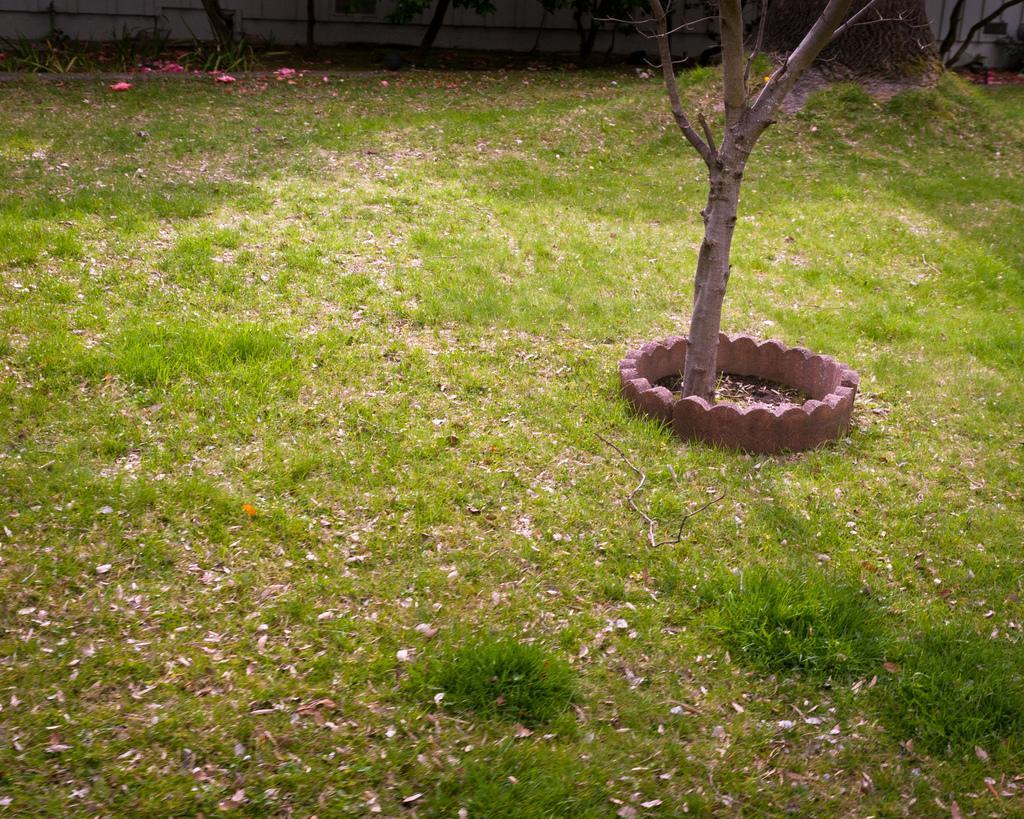Could you give a brief overview of what you see in this image? In the foreground of this image, there is a grassland. There is a tree in the middle and the stone boundary to it. On the top, it seems like there are trees and the wall. 